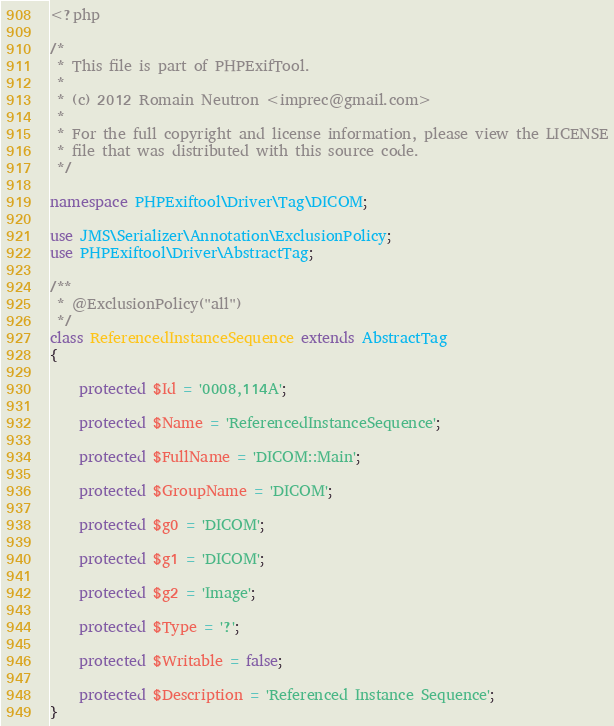Convert code to text. <code><loc_0><loc_0><loc_500><loc_500><_PHP_><?php

/*
 * This file is part of PHPExifTool.
 *
 * (c) 2012 Romain Neutron <imprec@gmail.com>
 *
 * For the full copyright and license information, please view the LICENSE
 * file that was distributed with this source code.
 */

namespace PHPExiftool\Driver\Tag\DICOM;

use JMS\Serializer\Annotation\ExclusionPolicy;
use PHPExiftool\Driver\AbstractTag;

/**
 * @ExclusionPolicy("all")
 */
class ReferencedInstanceSequence extends AbstractTag
{

    protected $Id = '0008,114A';

    protected $Name = 'ReferencedInstanceSequence';

    protected $FullName = 'DICOM::Main';

    protected $GroupName = 'DICOM';

    protected $g0 = 'DICOM';

    protected $g1 = 'DICOM';

    protected $g2 = 'Image';

    protected $Type = '?';

    protected $Writable = false;

    protected $Description = 'Referenced Instance Sequence';
}
</code> 